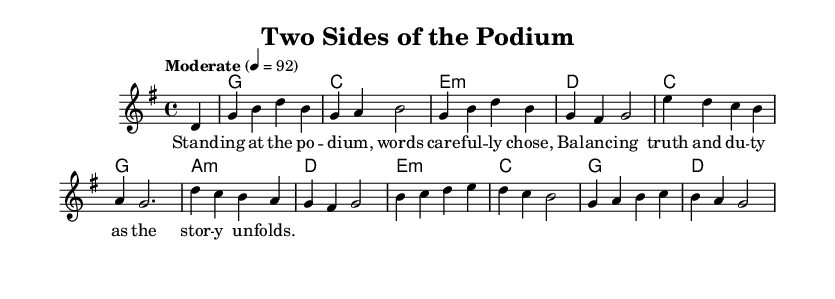What is the key signature of this music? The key signature is G major, which has one sharp (F#). This can be determined by looking at the key signature indicated at the beginning of the sheet music, specifically after the \key command.
Answer: G major What is the time signature of the music? The time signature is four-four, which is indicated by the \time command in the code. It means there are four beats in a measure, and the quarter note gets one beat.
Answer: four-four What is the tempo indication for this piece? The tempo indication is "Moderate" at quarter note equals 92. This is specified in the \tempo command and tells the performer the speed at which to play the piece.
Answer: Moderate How many measures are in the melody? The melody consists of ten measures. This can be counted by looking at the melody section and noting where each measure begins and ends.
Answer: ten What is the primary lyrical theme of this song? The primary lyrical theme of the song revolves around the balance between personal and professional life, as expressed in the lyrics "Balancing truth and duty..." which reflects the struggles of holding a public office.
Answer: balance between personal and professional life What chords are used in the first measure? The chords used in the first measure are G Major. This is determined by looking at the harmonies listed in the chord section corresponding to that measure.
Answer: G Major How does the melody reflect its Country Rock genre? The melody incorporates a simple yet catchy motif that emphasizes storytelling, a hallmark of Country Rock, along with the chord progressions typical of both country and rock music. This is seen in the overall structure and the lyrical content, focusing on personal introspection.
Answer: storytelling and catchy motifs 